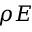Convert formula to latex. <formula><loc_0><loc_0><loc_500><loc_500>\rho E</formula> 